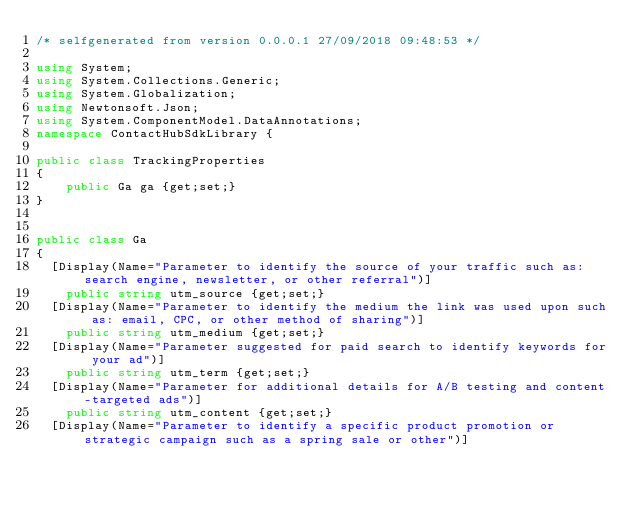<code> <loc_0><loc_0><loc_500><loc_500><_C#_>/* selfgenerated from version 0.0.0.1 27/09/2018 09:48:53 */

using System;
using System.Collections.Generic;
using System.Globalization;
using Newtonsoft.Json;
using System.ComponentModel.DataAnnotations;
namespace ContactHubSdkLibrary {

public class TrackingProperties
{
    public Ga ga {get;set;}
}


public class Ga
{
	[Display(Name="Parameter to identify the source of your traffic such as: search engine, newsletter, or other referral")]
    public string utm_source {get;set;}
	[Display(Name="Parameter to identify the medium the link was used upon such as: email, CPC, or other method of sharing")]
    public string utm_medium {get;set;}
	[Display(Name="Parameter suggested for paid search to identify keywords for your ad")]
    public string utm_term {get;set;}
	[Display(Name="Parameter for additional details for A/B testing and content-targeted ads")]
    public string utm_content {get;set;}
	[Display(Name="Parameter to identify a specific product promotion or strategic campaign such as a spring sale or other")]</code> 